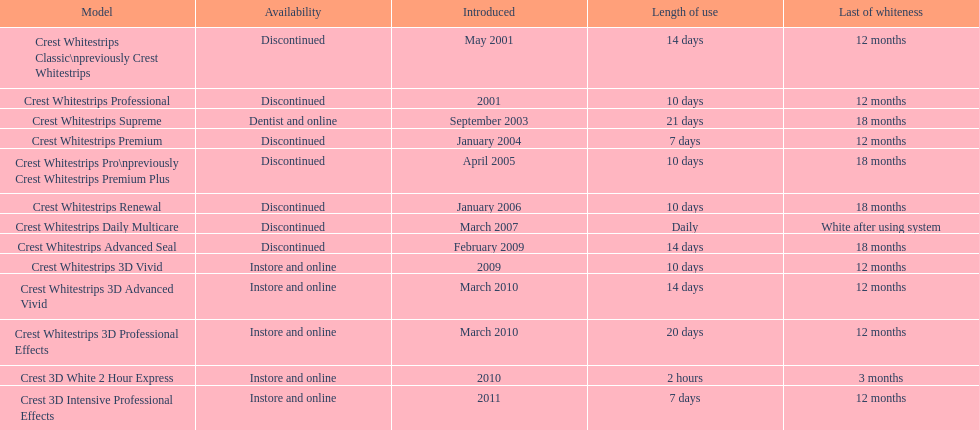How many products have been discontinued? 7. 